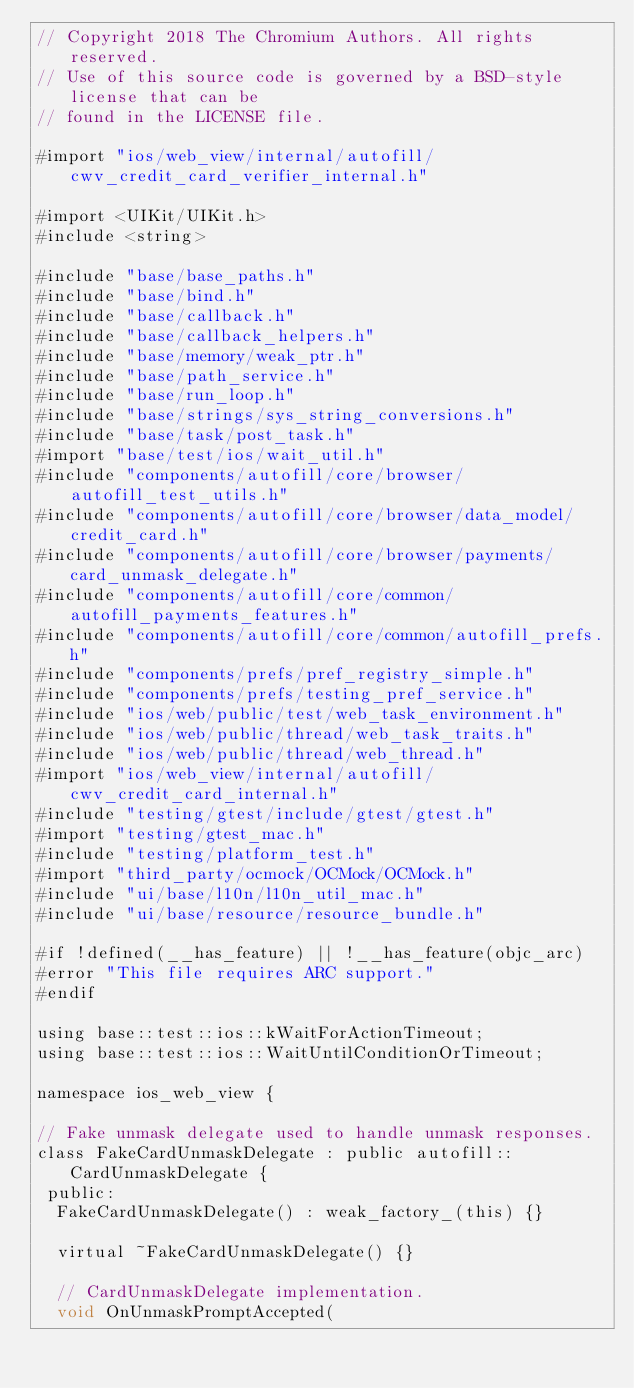<code> <loc_0><loc_0><loc_500><loc_500><_ObjectiveC_>// Copyright 2018 The Chromium Authors. All rights reserved.
// Use of this source code is governed by a BSD-style license that can be
// found in the LICENSE file.

#import "ios/web_view/internal/autofill/cwv_credit_card_verifier_internal.h"

#import <UIKit/UIKit.h>
#include <string>

#include "base/base_paths.h"
#include "base/bind.h"
#include "base/callback.h"
#include "base/callback_helpers.h"
#include "base/memory/weak_ptr.h"
#include "base/path_service.h"
#include "base/run_loop.h"
#include "base/strings/sys_string_conversions.h"
#include "base/task/post_task.h"
#import "base/test/ios/wait_util.h"
#include "components/autofill/core/browser/autofill_test_utils.h"
#include "components/autofill/core/browser/data_model/credit_card.h"
#include "components/autofill/core/browser/payments/card_unmask_delegate.h"
#include "components/autofill/core/common/autofill_payments_features.h"
#include "components/autofill/core/common/autofill_prefs.h"
#include "components/prefs/pref_registry_simple.h"
#include "components/prefs/testing_pref_service.h"
#include "ios/web/public/test/web_task_environment.h"
#include "ios/web/public/thread/web_task_traits.h"
#include "ios/web/public/thread/web_thread.h"
#import "ios/web_view/internal/autofill/cwv_credit_card_internal.h"
#include "testing/gtest/include/gtest/gtest.h"
#import "testing/gtest_mac.h"
#include "testing/platform_test.h"
#import "third_party/ocmock/OCMock/OCMock.h"
#include "ui/base/l10n/l10n_util_mac.h"
#include "ui/base/resource/resource_bundle.h"

#if !defined(__has_feature) || !__has_feature(objc_arc)
#error "This file requires ARC support."
#endif

using base::test::ios::kWaitForActionTimeout;
using base::test::ios::WaitUntilConditionOrTimeout;

namespace ios_web_view {

// Fake unmask delegate used to handle unmask responses.
class FakeCardUnmaskDelegate : public autofill::CardUnmaskDelegate {
 public:
  FakeCardUnmaskDelegate() : weak_factory_(this) {}

  virtual ~FakeCardUnmaskDelegate() {}

  // CardUnmaskDelegate implementation.
  void OnUnmaskPromptAccepted(</code> 